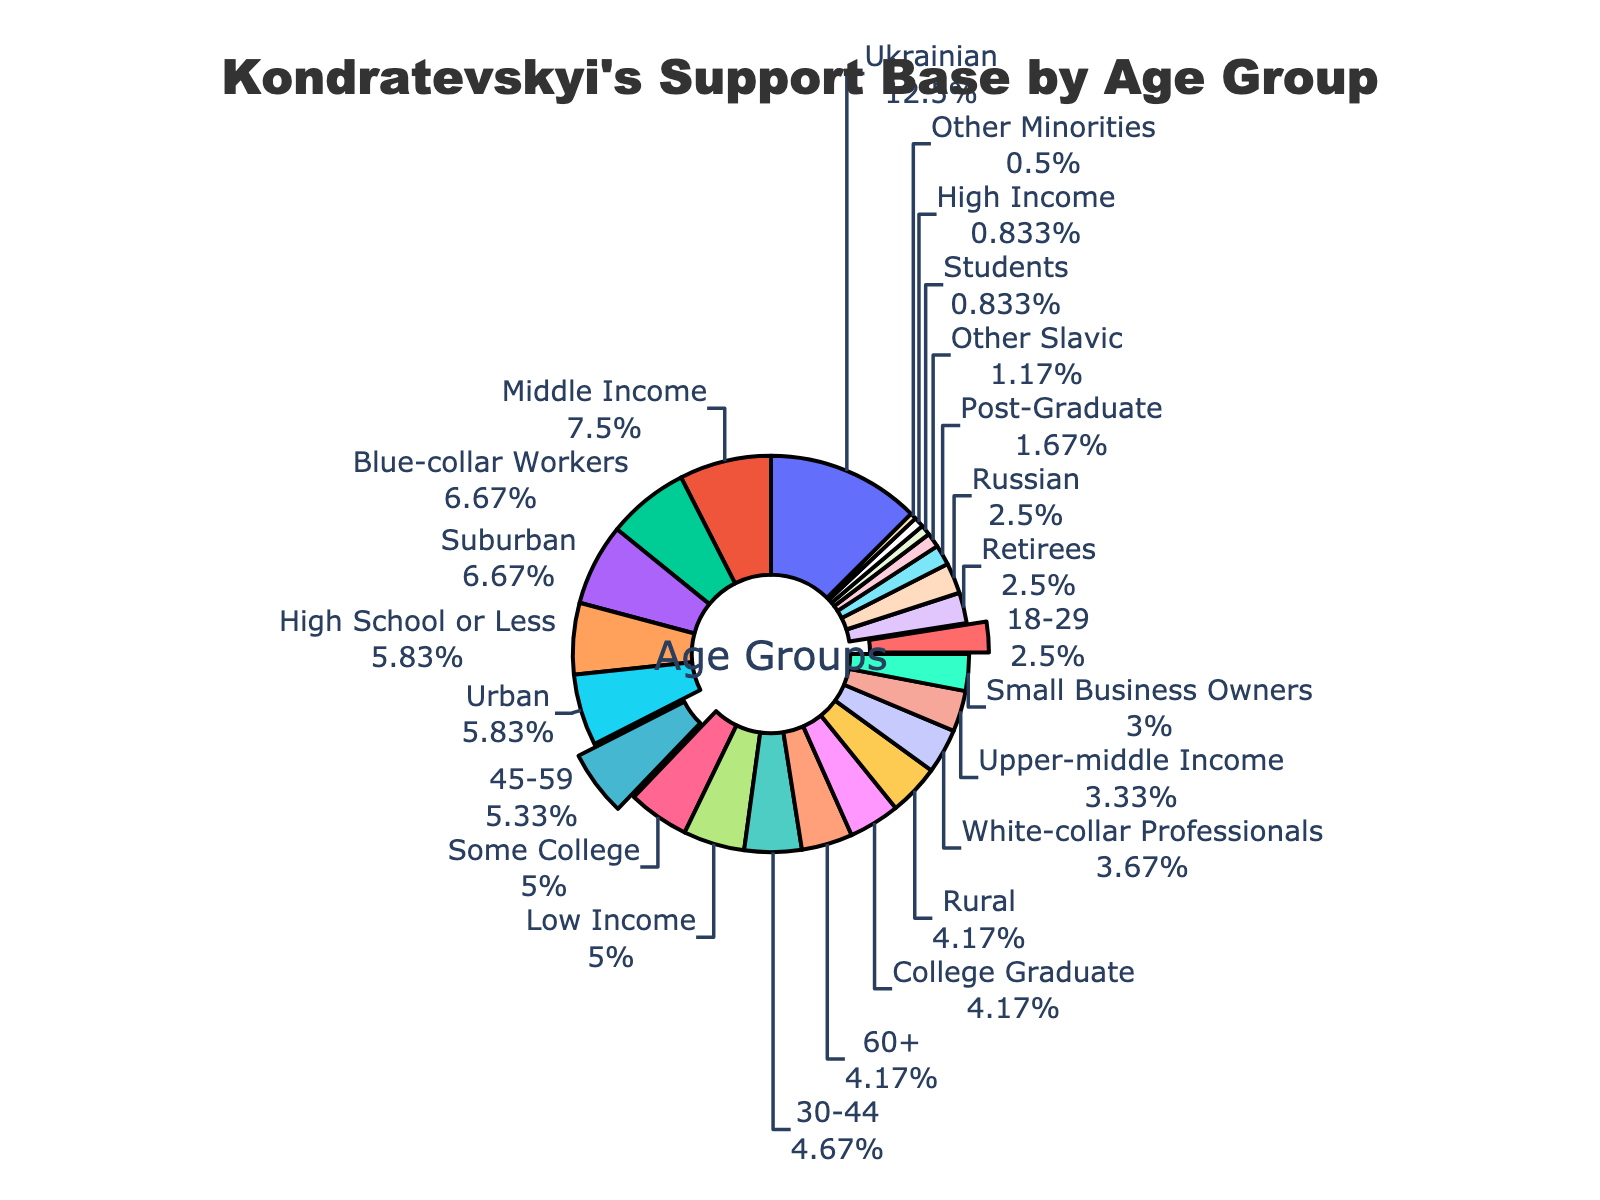What percentage of Kondratevskyi's support base is aged 45-59? Look at the figure and locate the age group "45-59." The value associated with this group is 32%.
Answer: 32% Which age group contains the largest percentage of Kondratevskyi's support base? Look at the percentages of each age group: 18-29 (15%), 30-44 (28%), 45-59 (32%), and 60+ (25%). The largest value is 32%, which corresponds to the 45-59 age group.
Answer: 45-59 How much greater is the percentage of 18-29 age group compared to the percentage of students? Identify the percentages of 18-29 (15%) and students (5%). Calculate the difference: 15% - 5% = 10%.
Answer: 10% What is the combined percentage of Kondratevskyi’s support base that are either white-collar professionals or small business owners? Identify the percentages of white-collar professionals (22%) and small business owners (18%). Sum them: 22% + 18% = 40%.
Answer: 40% Which category has a higher percentage: Those with a high school education or less, or those living in suburban areas? Find the percentages for high school or less education (35%) and suburban areas (40%). Compare them: 40% (suburban) is higher than 35% (high school or less).
Answer: Suburban areas What is the average percentage of support for the age groups 18-29 and 60+? Identify the percentages for 18-29 (15%) and 60+ (25%). Calculate the average: (15% + 25%) / 2 = 20%.
Answer: 20% Which occupation category has the smallest percentage of support, and what is that percentage? Look at the percentages of each occupation category. The smallest value is 5%, which corresponds to students.
Answer: Students, 5% Is the percentage of Kondratevskyi’s support base that is upper-middle income greater or less than the percentage of Russian ethnicity? Identify the percentages for upper-middle income (20%) and Russian ethnicity (15%). Compare them: 20% is greater than 15%.
Answer: Greater What is the difference between the percentage of supporters from urban and rural areas? Identify the percentages for urban (35%) and rural (25%) areas. Calculate the difference: 35% - 25% = 10%.
Answer: 10% Which age group is represented by the blue section in the pie chart? The blue section represents the age group with 28%, which corresponds to the 30-44 age group.
Answer: 30-44 